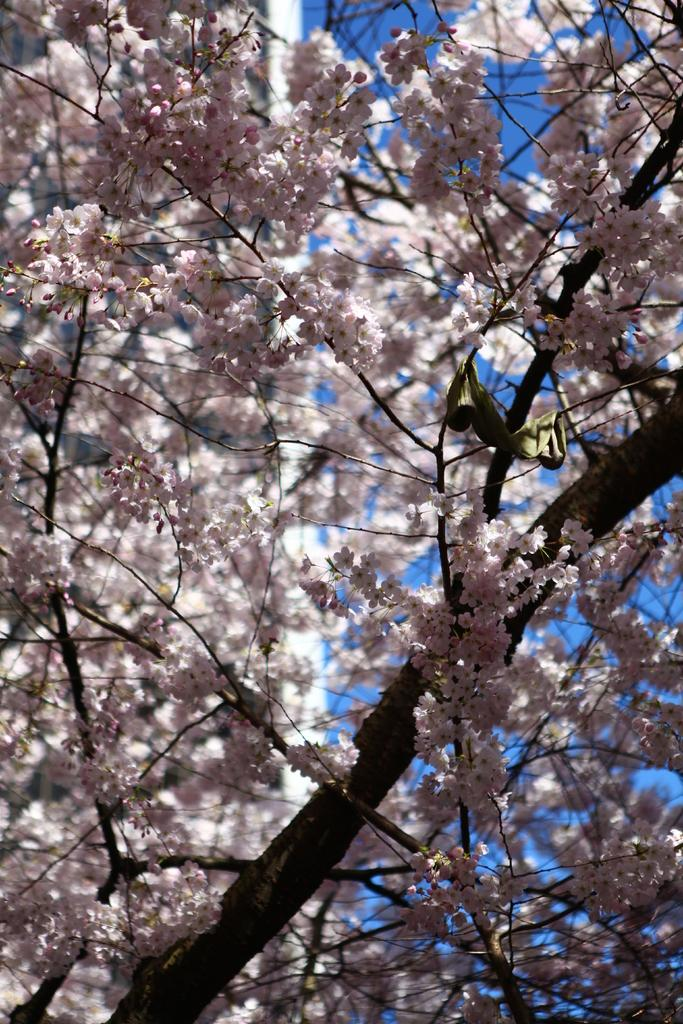What is the main subject of the image? The main subject of the image is a tree. What can be observed about the tree in the image? The tree has flowers, and it is in the center of the image. Can you tell me how many times the tree turns in the image? There is no indication that the tree is turning in the image; it is stationary. What type of wire is connected to the tree in the image? There is no wire connected to the tree in the image; it is a standalone tree with flowers. 